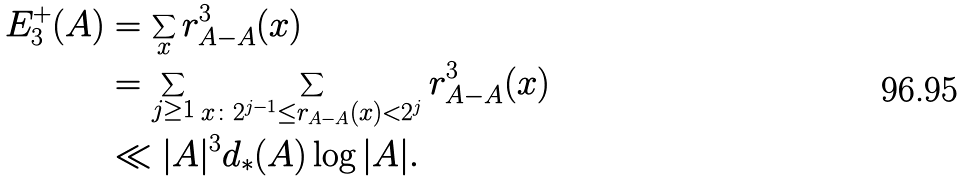<formula> <loc_0><loc_0><loc_500><loc_500>E _ { 3 } ^ { + } ( A ) & = \sum _ { x } r _ { A - A } ^ { 3 } ( x ) \\ & = \sum _ { j \geq 1 } \sum _ { x \colon 2 ^ { j - 1 } \leq r _ { A - A } ( x ) < 2 ^ { j } } r _ { A - A } ^ { 3 } ( x ) \\ & \ll | A | ^ { 3 } d _ { * } ( A ) \log | A | .</formula> 